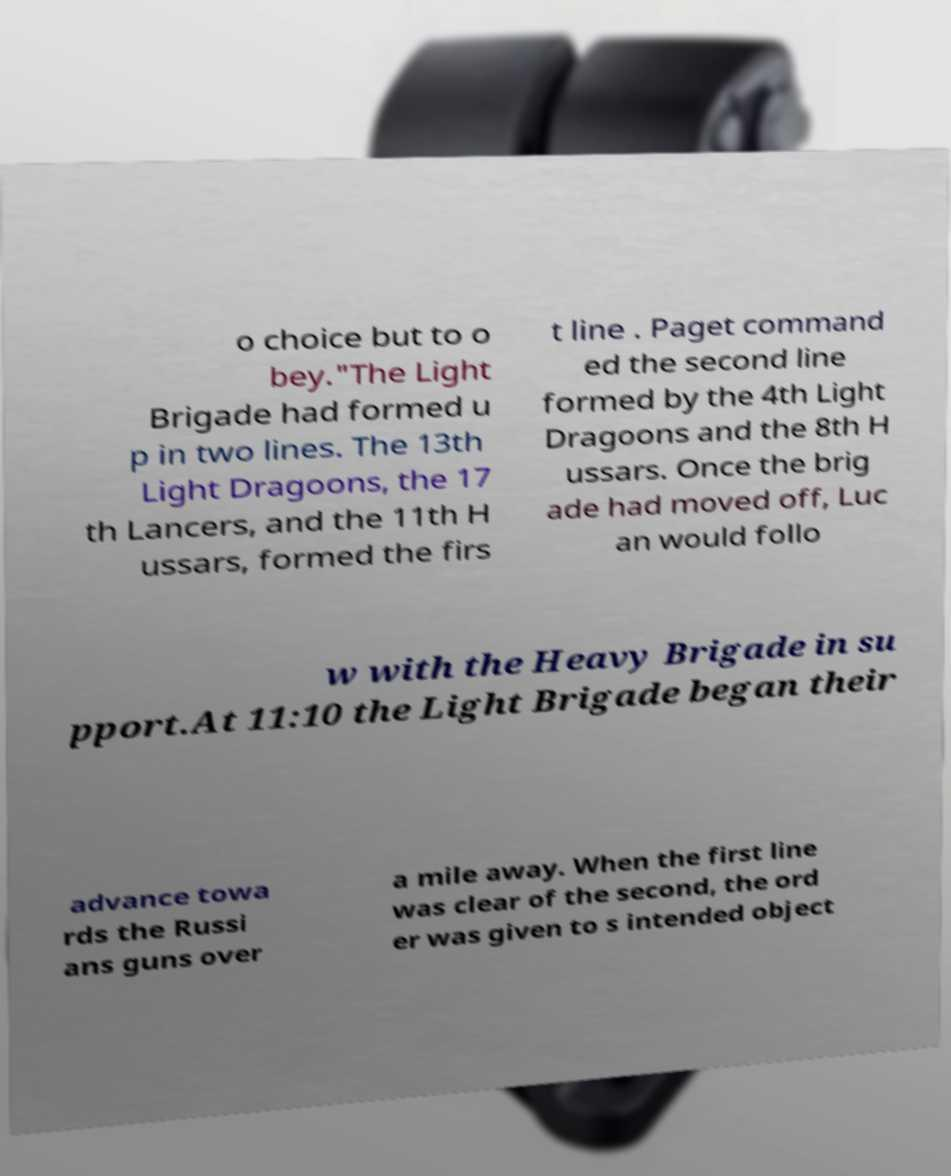What messages or text are displayed in this image? I need them in a readable, typed format. o choice but to o bey."The Light Brigade had formed u p in two lines. The 13th Light Dragoons, the 17 th Lancers, and the 11th H ussars, formed the firs t line . Paget command ed the second line formed by the 4th Light Dragoons and the 8th H ussars. Once the brig ade had moved off, Luc an would follo w with the Heavy Brigade in su pport.At 11:10 the Light Brigade began their advance towa rds the Russi ans guns over a mile away. When the first line was clear of the second, the ord er was given to s intended object 